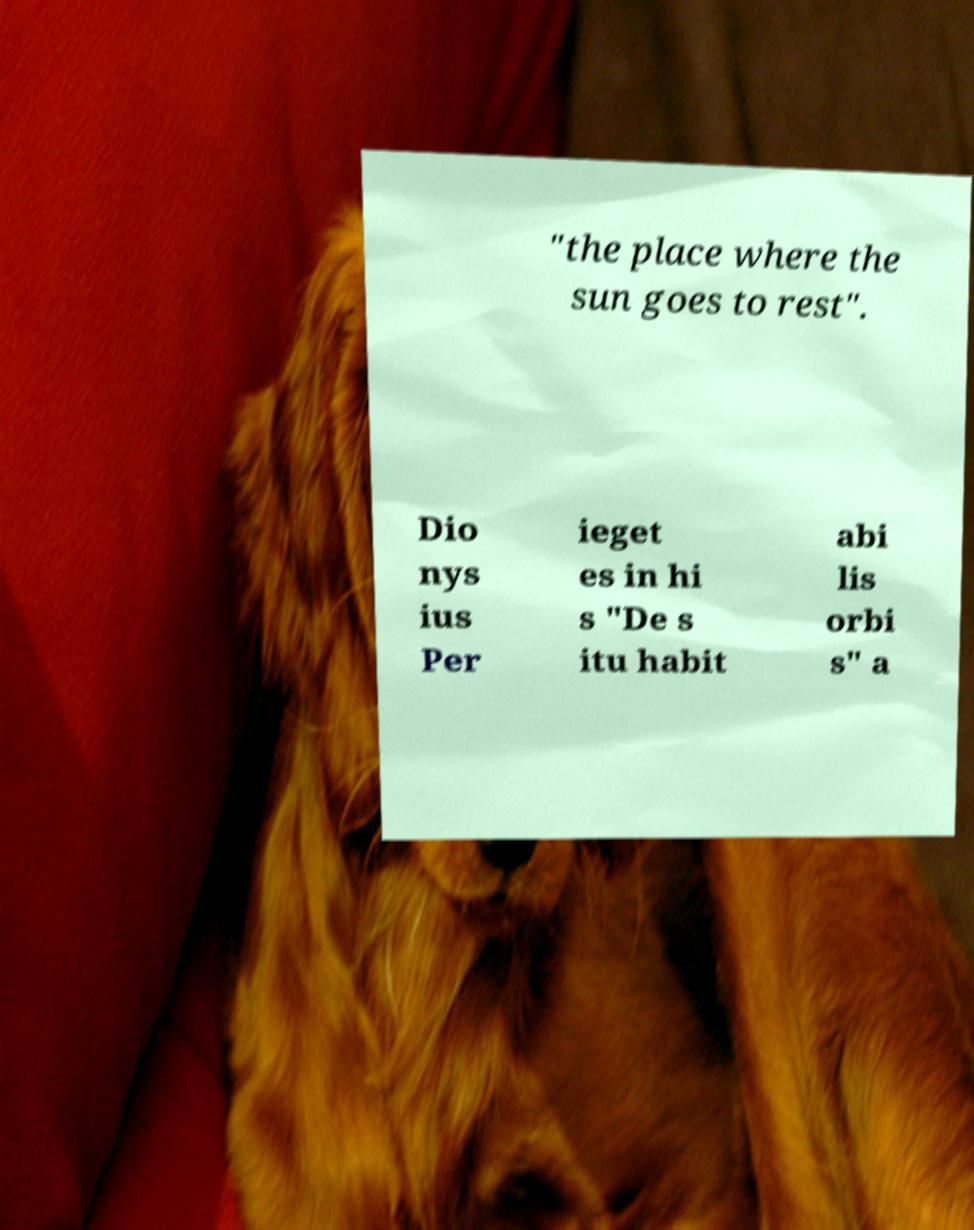Could you extract and type out the text from this image? "the place where the sun goes to rest". Dio nys ius Per ieget es in hi s "De s itu habit abi lis orbi s" a 